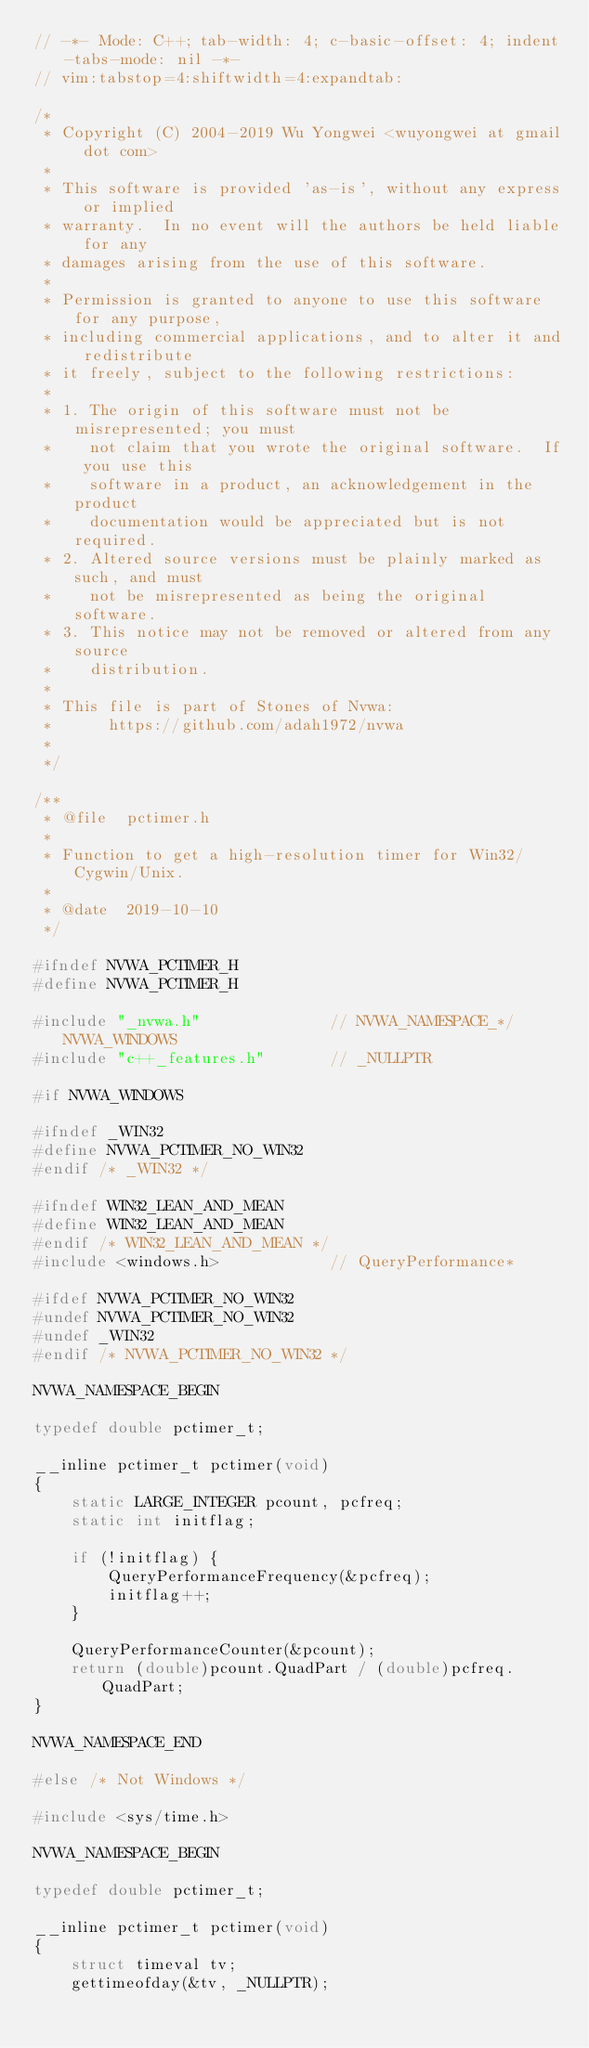Convert code to text. <code><loc_0><loc_0><loc_500><loc_500><_C_>// -*- Mode: C++; tab-width: 4; c-basic-offset: 4; indent-tabs-mode: nil -*-
// vim:tabstop=4:shiftwidth=4:expandtab:

/*
 * Copyright (C) 2004-2019 Wu Yongwei <wuyongwei at gmail dot com>
 *
 * This software is provided 'as-is', without any express or implied
 * warranty.  In no event will the authors be held liable for any
 * damages arising from the use of this software.
 *
 * Permission is granted to anyone to use this software for any purpose,
 * including commercial applications, and to alter it and redistribute
 * it freely, subject to the following restrictions:
 *
 * 1. The origin of this software must not be misrepresented; you must
 *    not claim that you wrote the original software.  If you use this
 *    software in a product, an acknowledgement in the product
 *    documentation would be appreciated but is not required.
 * 2. Altered source versions must be plainly marked as such, and must
 *    not be misrepresented as being the original software.
 * 3. This notice may not be removed or altered from any source
 *    distribution.
 *
 * This file is part of Stones of Nvwa:
 *      https://github.com/adah1972/nvwa
 *
 */

/**
 * @file  pctimer.h
 *
 * Function to get a high-resolution timer for Win32/Cygwin/Unix.
 *
 * @date  2019-10-10
 */

#ifndef NVWA_PCTIMER_H
#define NVWA_PCTIMER_H

#include "_nvwa.h"              // NVWA_NAMESPACE_*/NVWA_WINDOWS
#include "c++_features.h"       // _NULLPTR

#if NVWA_WINDOWS

#ifndef _WIN32
#define NVWA_PCTIMER_NO_WIN32
#endif /* _WIN32 */

#ifndef WIN32_LEAN_AND_MEAN
#define WIN32_LEAN_AND_MEAN
#endif /* WIN32_LEAN_AND_MEAN */
#include <windows.h>            // QueryPerformance*

#ifdef NVWA_PCTIMER_NO_WIN32
#undef NVWA_PCTIMER_NO_WIN32
#undef _WIN32
#endif /* NVWA_PCTIMER_NO_WIN32 */

NVWA_NAMESPACE_BEGIN

typedef double pctimer_t;

__inline pctimer_t pctimer(void)
{
    static LARGE_INTEGER pcount, pcfreq;
    static int initflag;

    if (!initflag) {
        QueryPerformanceFrequency(&pcfreq);
        initflag++;
    }

    QueryPerformanceCounter(&pcount);
    return (double)pcount.QuadPart / (double)pcfreq.QuadPart;
}

NVWA_NAMESPACE_END

#else /* Not Windows */

#include <sys/time.h>

NVWA_NAMESPACE_BEGIN

typedef double pctimer_t;

__inline pctimer_t pctimer(void)
{
    struct timeval tv;
    gettimeofday(&tv, _NULLPTR);</code> 